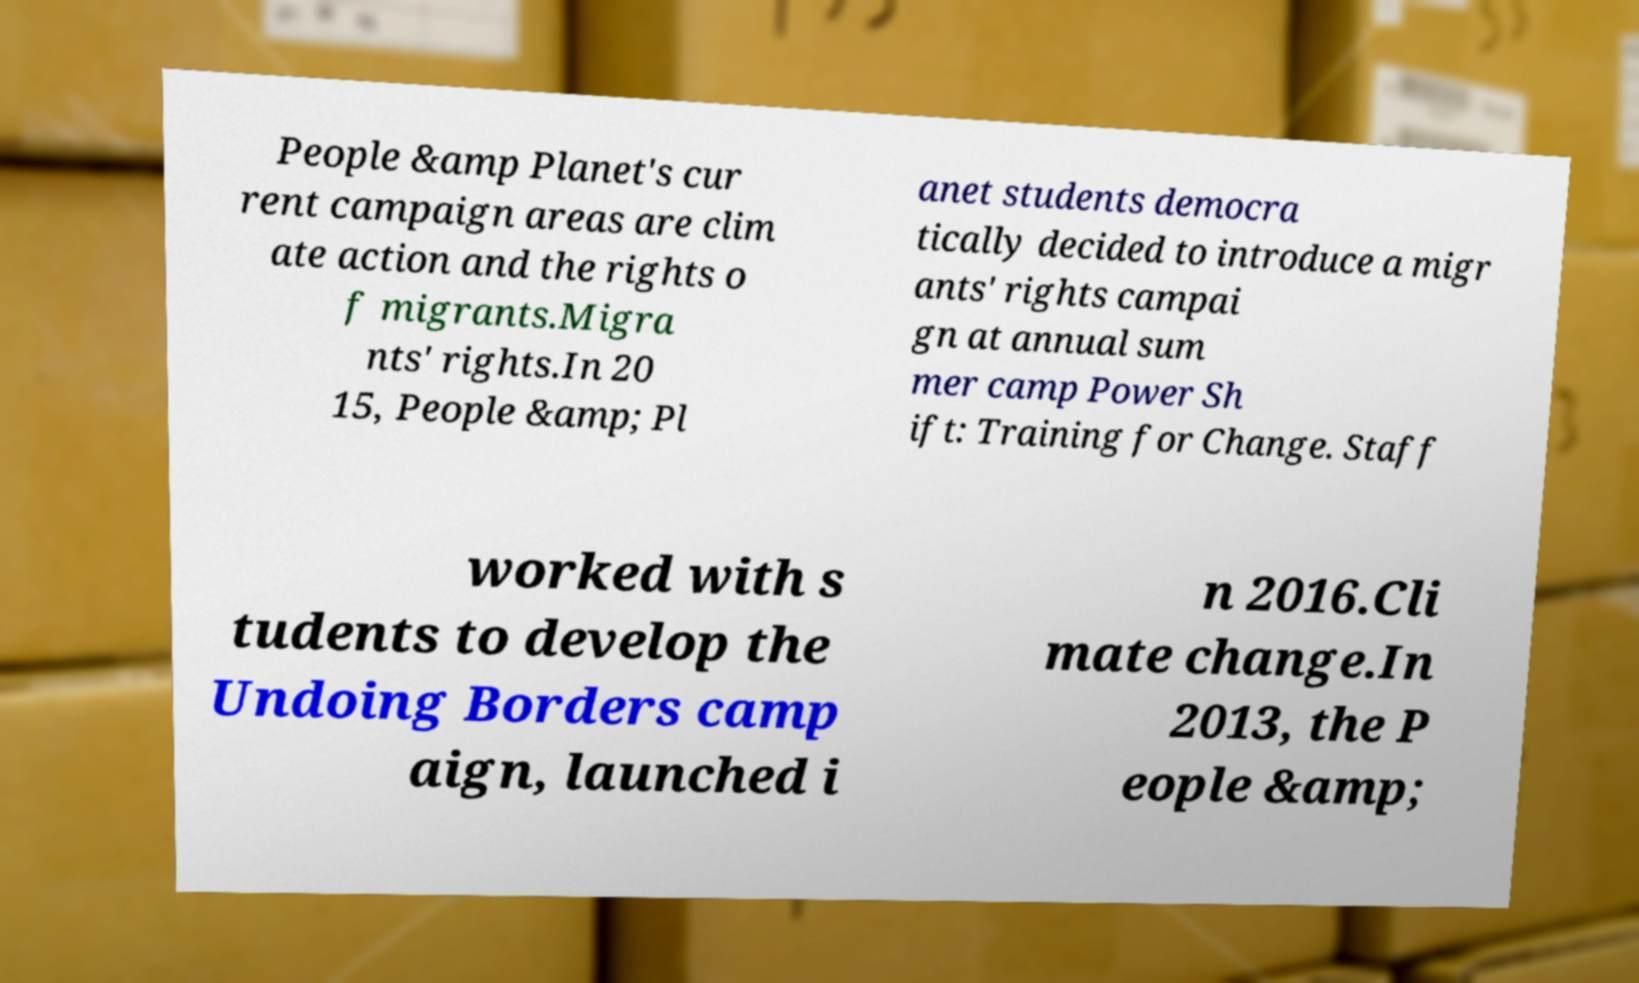Could you extract and type out the text from this image? People &amp Planet's cur rent campaign areas are clim ate action and the rights o f migrants.Migra nts' rights.In 20 15, People &amp; Pl anet students democra tically decided to introduce a migr ants' rights campai gn at annual sum mer camp Power Sh ift: Training for Change. Staff worked with s tudents to develop the Undoing Borders camp aign, launched i n 2016.Cli mate change.In 2013, the P eople &amp; 